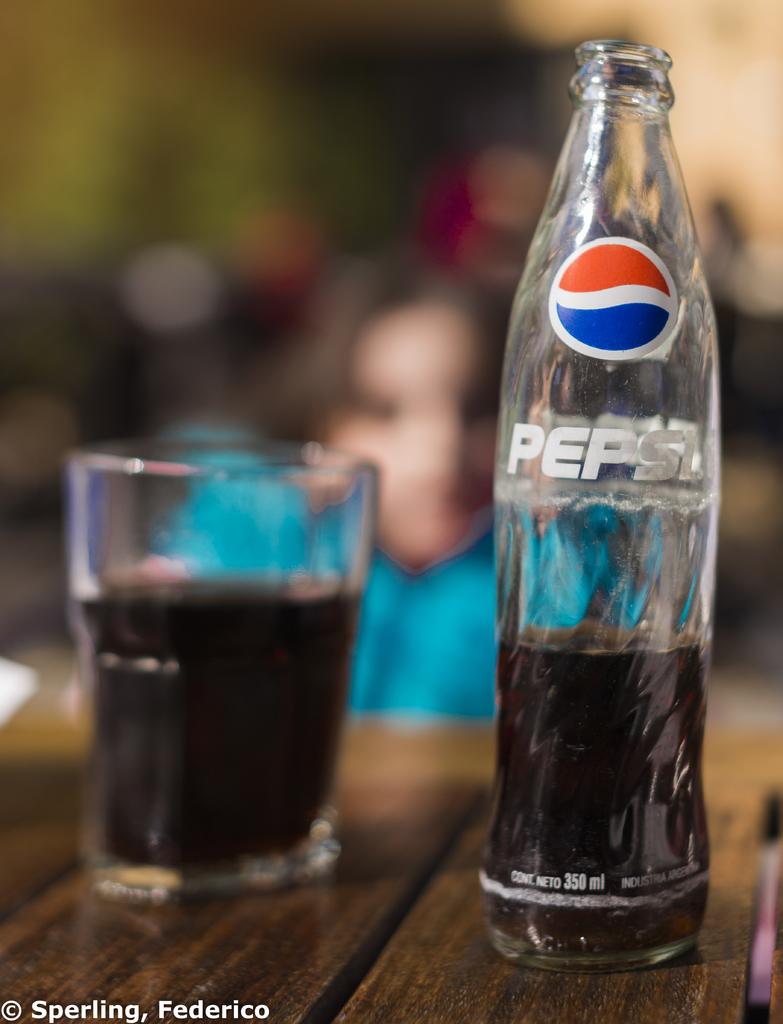What soda is in the bottle?
Provide a short and direct response. Pepsi. How many ml's can this bottle hold?
Make the answer very short. 350. 